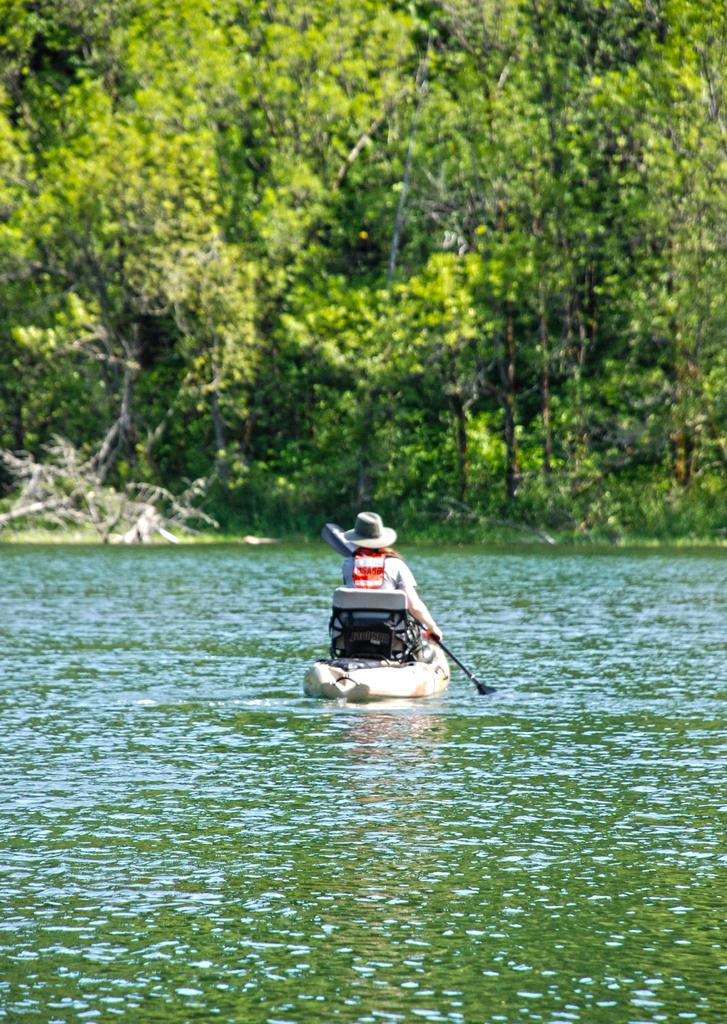What is the person in the image doing? The person is rowing a boat. Where is the boat located in the image? The boat is in the middle of a lake. What can be seen in the background of the image? There are trees in the background of the image. What type of gun is being used by the person in the image? There is no gun present in the image; the person is rowing a boat. Can you describe the mist in the image? There is no mist present in the image; it features a person rowing a boat in the middle of a lake with trees in the background. 